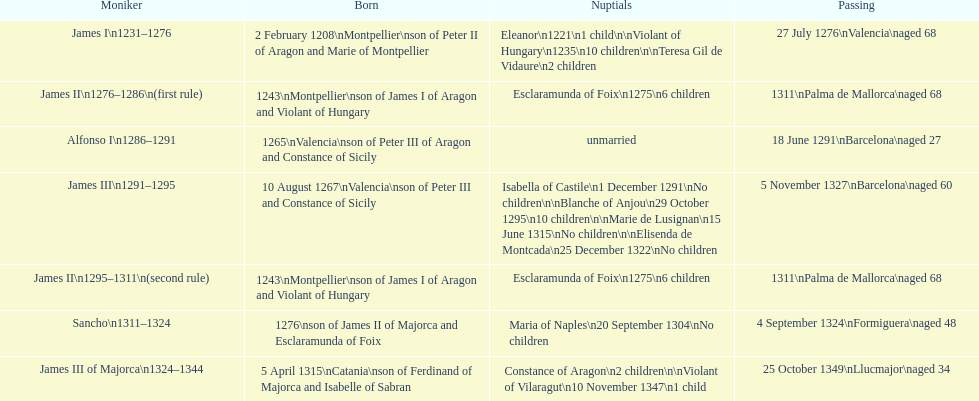How many total marriages did james i have? 3. 